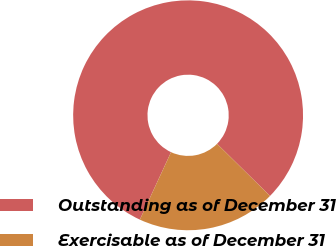Convert chart to OTSL. <chart><loc_0><loc_0><loc_500><loc_500><pie_chart><fcel>Outstanding as of December 31<fcel>Exercisable as of December 31<nl><fcel>80.48%<fcel>19.52%<nl></chart> 